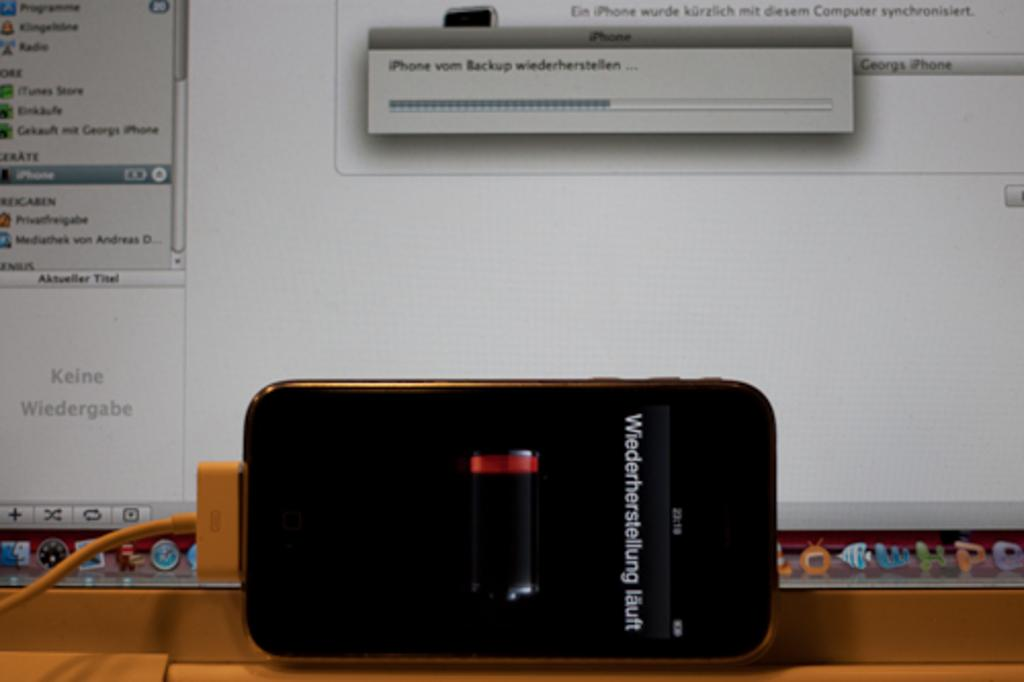<image>
Relay a brief, clear account of the picture shown. An iPhone, which displays the text Wiederherstellung lault, is hooked up to a computer. 